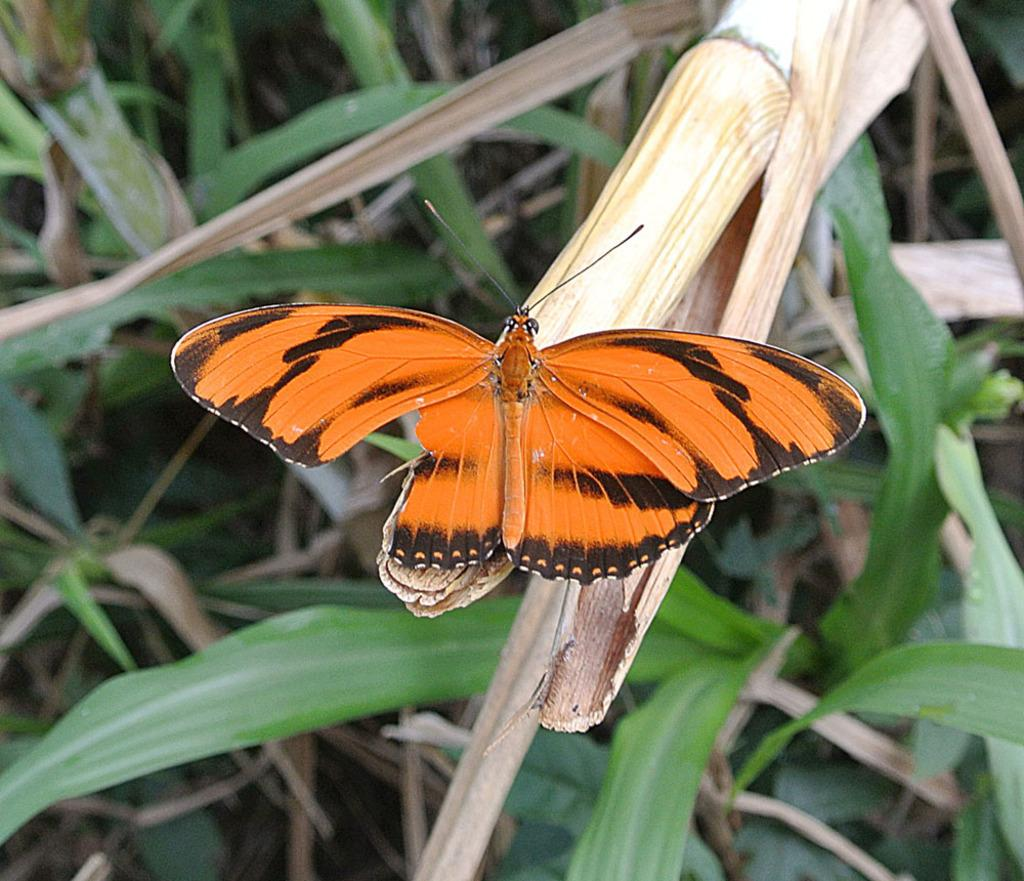What is the main subject of the image? The main subject of the image is a butterfly. Where is the butterfly located in the image? The butterfly is on an object that looks like a sugarcane plant. What else can be seen in the image besides the butterfly? There are plants on the ground in the image. What type of ice can be seen melting on the butterfly's wings in the image? There is no ice present on the butterfly's wings in the image. How many pets are visible in the image? There are no pets visible in the image; it features a butterfly on a sugarcane plant and plants on the ground. 